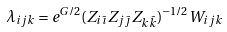<formula> <loc_0><loc_0><loc_500><loc_500>\lambda _ { i j k } = e ^ { G / 2 } ( Z _ { i \bar { \imath } } Z _ { j \bar { \jmath } } Z _ { k \bar { k } } ) ^ { - 1 / 2 } W _ { i j k }</formula> 